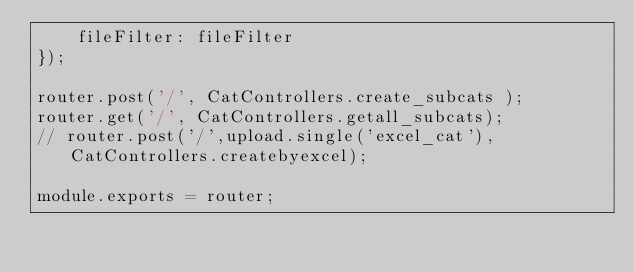<code> <loc_0><loc_0><loc_500><loc_500><_JavaScript_>    fileFilter: fileFilter
});

router.post('/', CatControllers.create_subcats );
router.get('/', CatControllers.getall_subcats);
// router.post('/',upload.single('excel_cat'), CatControllers.createbyexcel);

module.exports = router;</code> 